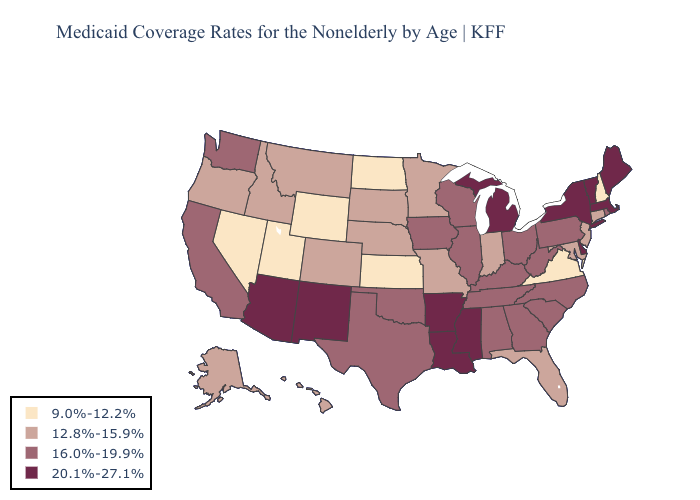Does the first symbol in the legend represent the smallest category?
Be succinct. Yes. Among the states that border Texas , which have the lowest value?
Give a very brief answer. Oklahoma. Among the states that border South Dakota , does Iowa have the lowest value?
Concise answer only. No. Name the states that have a value in the range 9.0%-12.2%?
Write a very short answer. Kansas, Nevada, New Hampshire, North Dakota, Utah, Virginia, Wyoming. Is the legend a continuous bar?
Short answer required. No. What is the highest value in the Northeast ?
Short answer required. 20.1%-27.1%. What is the value of Connecticut?
Give a very brief answer. 12.8%-15.9%. Among the states that border Arkansas , which have the lowest value?
Keep it brief. Missouri. Among the states that border Nevada , which have the highest value?
Short answer required. Arizona. What is the value of Maine?
Answer briefly. 20.1%-27.1%. What is the value of Texas?
Answer briefly. 16.0%-19.9%. Among the states that border Utah , does New Mexico have the highest value?
Be succinct. Yes. Does Nebraska have a higher value than North Dakota?
Short answer required. Yes. Name the states that have a value in the range 16.0%-19.9%?
Short answer required. Alabama, California, Georgia, Illinois, Iowa, Kentucky, North Carolina, Ohio, Oklahoma, Pennsylvania, Rhode Island, South Carolina, Tennessee, Texas, Washington, West Virginia, Wisconsin. 